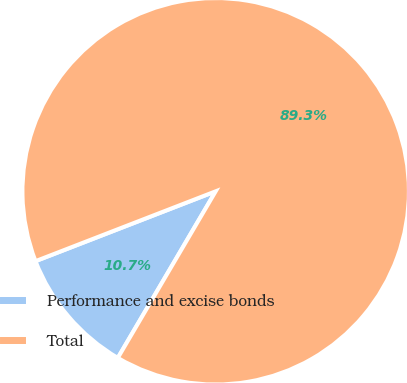Convert chart. <chart><loc_0><loc_0><loc_500><loc_500><pie_chart><fcel>Performance and excise bonds<fcel>Total<nl><fcel>10.66%<fcel>89.34%<nl></chart> 